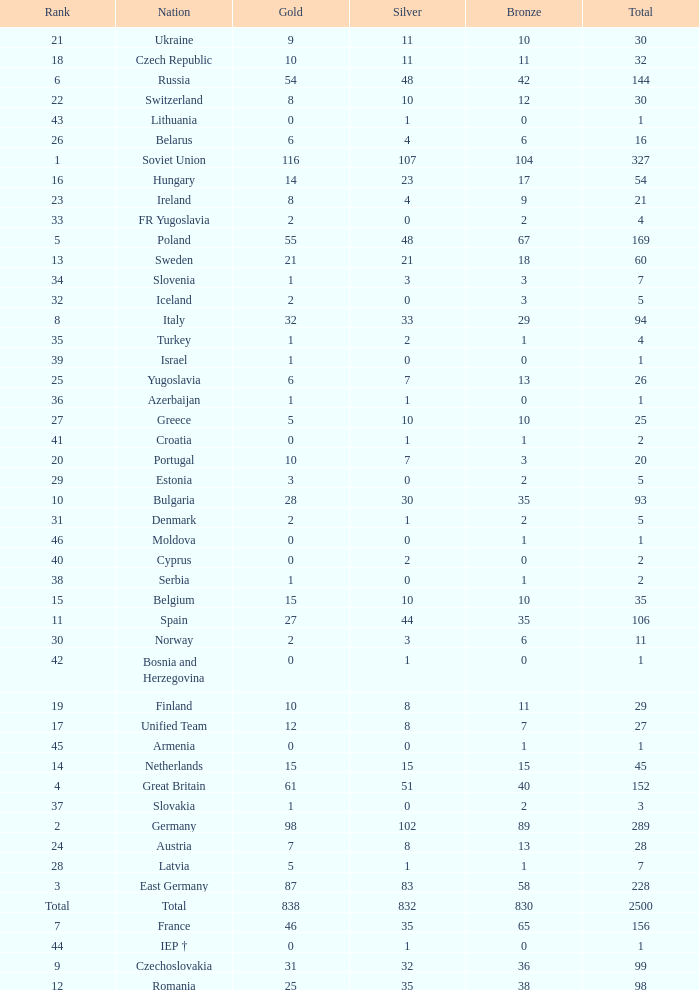What is the rank of the nation with more than 0 silver medals and 38 bronze medals? 12.0. 